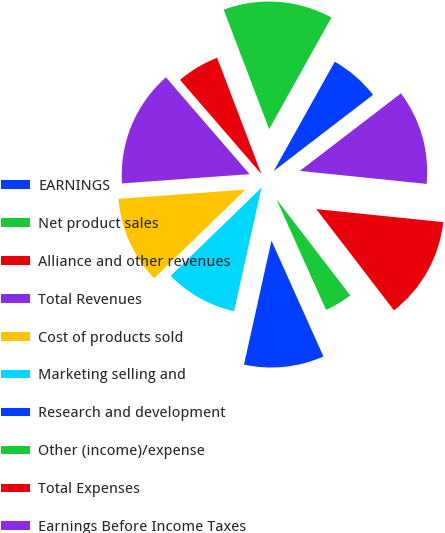Convert chart to OTSL. <chart><loc_0><loc_0><loc_500><loc_500><pie_chart><fcel>EARNINGS<fcel>Net product sales<fcel>Alliance and other revenues<fcel>Total Revenues<fcel>Cost of products sold<fcel>Marketing selling and<fcel>Research and development<fcel>Other (income)/expense<fcel>Total Expenses<fcel>Earnings Before Income Taxes<nl><fcel>6.48%<fcel>13.89%<fcel>5.56%<fcel>14.81%<fcel>11.11%<fcel>9.26%<fcel>10.19%<fcel>3.7%<fcel>12.96%<fcel>12.04%<nl></chart> 